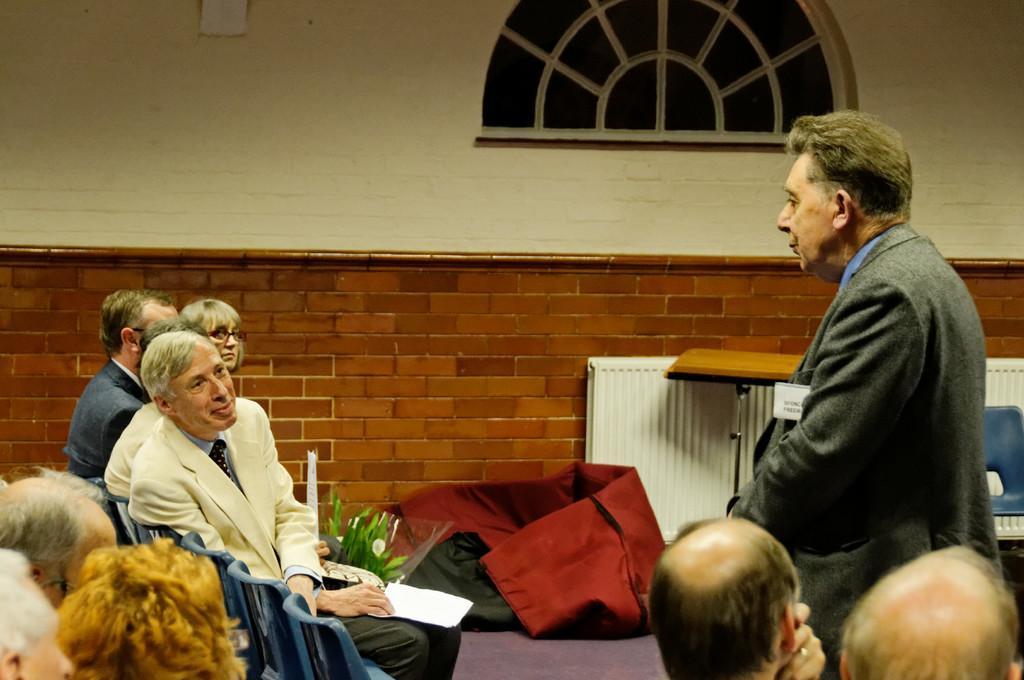How would you summarize this image in a sentence or two? In this image we can see a man is standing, he is wearing grey color coat. In front of him people are sitting on the blue color chairs. Right bottom of the image two persons are there. Background of the image white and brown color brick wall, table, glass window, chair and red color cloth like thing is there on the floor. 